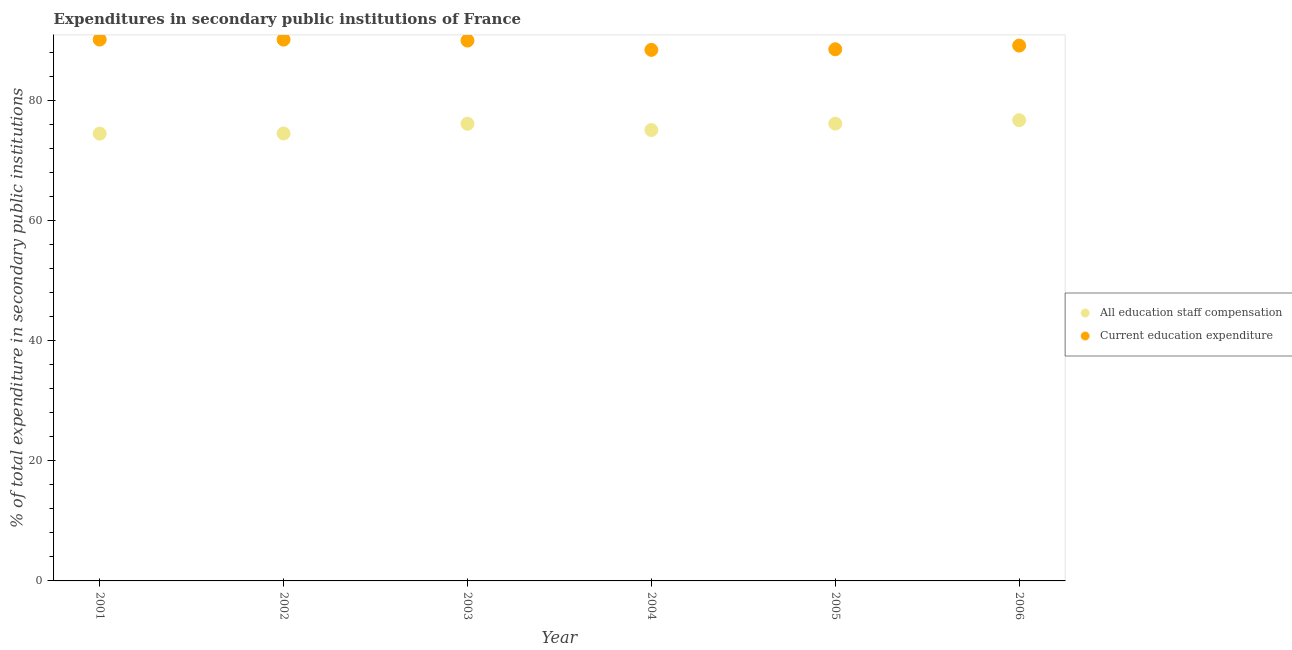What is the expenditure in education in 2003?
Your response must be concise. 90.03. Across all years, what is the maximum expenditure in staff compensation?
Keep it short and to the point. 76.76. Across all years, what is the minimum expenditure in education?
Give a very brief answer. 88.48. In which year was the expenditure in staff compensation minimum?
Your answer should be very brief. 2001. What is the total expenditure in education in the graph?
Offer a very short reply. 536.65. What is the difference between the expenditure in education in 2003 and that in 2004?
Provide a short and direct response. 1.55. What is the difference between the expenditure in education in 2001 and the expenditure in staff compensation in 2005?
Give a very brief answer. 14. What is the average expenditure in staff compensation per year?
Your answer should be very brief. 75.55. In the year 2004, what is the difference between the expenditure in education and expenditure in staff compensation?
Your response must be concise. 13.35. In how many years, is the expenditure in education greater than 44 %?
Provide a succinct answer. 6. What is the ratio of the expenditure in staff compensation in 2004 to that in 2006?
Offer a very short reply. 0.98. Is the difference between the expenditure in staff compensation in 2002 and 2005 greater than the difference between the expenditure in education in 2002 and 2005?
Your answer should be very brief. No. What is the difference between the highest and the second highest expenditure in staff compensation?
Your answer should be very brief. 0.57. What is the difference between the highest and the lowest expenditure in staff compensation?
Your response must be concise. 2.24. Is the sum of the expenditure in staff compensation in 2003 and 2004 greater than the maximum expenditure in education across all years?
Offer a very short reply. Yes. Is the expenditure in education strictly less than the expenditure in staff compensation over the years?
Your answer should be very brief. No. How many dotlines are there?
Offer a terse response. 2. What is the difference between two consecutive major ticks on the Y-axis?
Provide a short and direct response. 20. Does the graph contain any zero values?
Make the answer very short. No. Where does the legend appear in the graph?
Your answer should be very brief. Center right. What is the title of the graph?
Make the answer very short. Expenditures in secondary public institutions of France. Does "Measles" appear as one of the legend labels in the graph?
Provide a succinct answer. No. What is the label or title of the X-axis?
Offer a terse response. Year. What is the label or title of the Y-axis?
Your response must be concise. % of total expenditure in secondary public institutions. What is the % of total expenditure in secondary public institutions in All education staff compensation in 2001?
Your response must be concise. 74.53. What is the % of total expenditure in secondary public institutions in Current education expenditure in 2001?
Keep it short and to the point. 90.19. What is the % of total expenditure in secondary public institutions in All education staff compensation in 2002?
Provide a short and direct response. 74.55. What is the % of total expenditure in secondary public institutions in Current education expenditure in 2002?
Provide a succinct answer. 90.19. What is the % of total expenditure in secondary public institutions in All education staff compensation in 2003?
Make the answer very short. 76.16. What is the % of total expenditure in secondary public institutions of Current education expenditure in 2003?
Give a very brief answer. 90.03. What is the % of total expenditure in secondary public institutions of All education staff compensation in 2004?
Provide a succinct answer. 75.12. What is the % of total expenditure in secondary public institutions in Current education expenditure in 2004?
Your answer should be compact. 88.48. What is the % of total expenditure in secondary public institutions in All education staff compensation in 2005?
Ensure brevity in your answer.  76.19. What is the % of total expenditure in secondary public institutions in Current education expenditure in 2005?
Offer a very short reply. 88.58. What is the % of total expenditure in secondary public institutions in All education staff compensation in 2006?
Your answer should be compact. 76.76. What is the % of total expenditure in secondary public institutions in Current education expenditure in 2006?
Give a very brief answer. 89.19. Across all years, what is the maximum % of total expenditure in secondary public institutions in All education staff compensation?
Keep it short and to the point. 76.76. Across all years, what is the maximum % of total expenditure in secondary public institutions of Current education expenditure?
Provide a succinct answer. 90.19. Across all years, what is the minimum % of total expenditure in secondary public institutions in All education staff compensation?
Offer a very short reply. 74.53. Across all years, what is the minimum % of total expenditure in secondary public institutions in Current education expenditure?
Make the answer very short. 88.48. What is the total % of total expenditure in secondary public institutions of All education staff compensation in the graph?
Keep it short and to the point. 453.31. What is the total % of total expenditure in secondary public institutions of Current education expenditure in the graph?
Make the answer very short. 536.65. What is the difference between the % of total expenditure in secondary public institutions of All education staff compensation in 2001 and that in 2002?
Your answer should be very brief. -0.02. What is the difference between the % of total expenditure in secondary public institutions in Current education expenditure in 2001 and that in 2002?
Ensure brevity in your answer.  0. What is the difference between the % of total expenditure in secondary public institutions in All education staff compensation in 2001 and that in 2003?
Ensure brevity in your answer.  -1.64. What is the difference between the % of total expenditure in secondary public institutions of Current education expenditure in 2001 and that in 2003?
Make the answer very short. 0.17. What is the difference between the % of total expenditure in secondary public institutions in All education staff compensation in 2001 and that in 2004?
Ensure brevity in your answer.  -0.6. What is the difference between the % of total expenditure in secondary public institutions of Current education expenditure in 2001 and that in 2004?
Ensure brevity in your answer.  1.72. What is the difference between the % of total expenditure in secondary public institutions in All education staff compensation in 2001 and that in 2005?
Offer a terse response. -1.66. What is the difference between the % of total expenditure in secondary public institutions in Current education expenditure in 2001 and that in 2005?
Your response must be concise. 1.61. What is the difference between the % of total expenditure in secondary public institutions of All education staff compensation in 2001 and that in 2006?
Your answer should be compact. -2.24. What is the difference between the % of total expenditure in secondary public institutions in Current education expenditure in 2001 and that in 2006?
Your answer should be compact. 1. What is the difference between the % of total expenditure in secondary public institutions in All education staff compensation in 2002 and that in 2003?
Provide a succinct answer. -1.61. What is the difference between the % of total expenditure in secondary public institutions of Current education expenditure in 2002 and that in 2003?
Make the answer very short. 0.16. What is the difference between the % of total expenditure in secondary public institutions of All education staff compensation in 2002 and that in 2004?
Give a very brief answer. -0.57. What is the difference between the % of total expenditure in secondary public institutions of Current education expenditure in 2002 and that in 2004?
Your response must be concise. 1.71. What is the difference between the % of total expenditure in secondary public institutions in All education staff compensation in 2002 and that in 2005?
Keep it short and to the point. -1.64. What is the difference between the % of total expenditure in secondary public institutions in Current education expenditure in 2002 and that in 2005?
Your answer should be compact. 1.61. What is the difference between the % of total expenditure in secondary public institutions of All education staff compensation in 2002 and that in 2006?
Your answer should be compact. -2.21. What is the difference between the % of total expenditure in secondary public institutions in Current education expenditure in 2002 and that in 2006?
Provide a succinct answer. 1. What is the difference between the % of total expenditure in secondary public institutions of All education staff compensation in 2003 and that in 2004?
Offer a very short reply. 1.04. What is the difference between the % of total expenditure in secondary public institutions of Current education expenditure in 2003 and that in 2004?
Offer a very short reply. 1.55. What is the difference between the % of total expenditure in secondary public institutions of All education staff compensation in 2003 and that in 2005?
Your answer should be compact. -0.03. What is the difference between the % of total expenditure in secondary public institutions in Current education expenditure in 2003 and that in 2005?
Give a very brief answer. 1.45. What is the difference between the % of total expenditure in secondary public institutions in All education staff compensation in 2003 and that in 2006?
Offer a very short reply. -0.6. What is the difference between the % of total expenditure in secondary public institutions of Current education expenditure in 2003 and that in 2006?
Offer a terse response. 0.84. What is the difference between the % of total expenditure in secondary public institutions of All education staff compensation in 2004 and that in 2005?
Offer a terse response. -1.07. What is the difference between the % of total expenditure in secondary public institutions of Current education expenditure in 2004 and that in 2005?
Your response must be concise. -0.1. What is the difference between the % of total expenditure in secondary public institutions in All education staff compensation in 2004 and that in 2006?
Keep it short and to the point. -1.64. What is the difference between the % of total expenditure in secondary public institutions in Current education expenditure in 2004 and that in 2006?
Ensure brevity in your answer.  -0.72. What is the difference between the % of total expenditure in secondary public institutions in All education staff compensation in 2005 and that in 2006?
Provide a short and direct response. -0.57. What is the difference between the % of total expenditure in secondary public institutions in Current education expenditure in 2005 and that in 2006?
Provide a succinct answer. -0.61. What is the difference between the % of total expenditure in secondary public institutions of All education staff compensation in 2001 and the % of total expenditure in secondary public institutions of Current education expenditure in 2002?
Offer a terse response. -15.66. What is the difference between the % of total expenditure in secondary public institutions of All education staff compensation in 2001 and the % of total expenditure in secondary public institutions of Current education expenditure in 2003?
Offer a terse response. -15.5. What is the difference between the % of total expenditure in secondary public institutions of All education staff compensation in 2001 and the % of total expenditure in secondary public institutions of Current education expenditure in 2004?
Give a very brief answer. -13.95. What is the difference between the % of total expenditure in secondary public institutions of All education staff compensation in 2001 and the % of total expenditure in secondary public institutions of Current education expenditure in 2005?
Your answer should be compact. -14.05. What is the difference between the % of total expenditure in secondary public institutions of All education staff compensation in 2001 and the % of total expenditure in secondary public institutions of Current education expenditure in 2006?
Give a very brief answer. -14.67. What is the difference between the % of total expenditure in secondary public institutions of All education staff compensation in 2002 and the % of total expenditure in secondary public institutions of Current education expenditure in 2003?
Provide a succinct answer. -15.48. What is the difference between the % of total expenditure in secondary public institutions of All education staff compensation in 2002 and the % of total expenditure in secondary public institutions of Current education expenditure in 2004?
Offer a very short reply. -13.93. What is the difference between the % of total expenditure in secondary public institutions of All education staff compensation in 2002 and the % of total expenditure in secondary public institutions of Current education expenditure in 2005?
Offer a very short reply. -14.03. What is the difference between the % of total expenditure in secondary public institutions in All education staff compensation in 2002 and the % of total expenditure in secondary public institutions in Current education expenditure in 2006?
Provide a succinct answer. -14.64. What is the difference between the % of total expenditure in secondary public institutions of All education staff compensation in 2003 and the % of total expenditure in secondary public institutions of Current education expenditure in 2004?
Keep it short and to the point. -12.31. What is the difference between the % of total expenditure in secondary public institutions in All education staff compensation in 2003 and the % of total expenditure in secondary public institutions in Current education expenditure in 2005?
Give a very brief answer. -12.41. What is the difference between the % of total expenditure in secondary public institutions in All education staff compensation in 2003 and the % of total expenditure in secondary public institutions in Current education expenditure in 2006?
Provide a short and direct response. -13.03. What is the difference between the % of total expenditure in secondary public institutions of All education staff compensation in 2004 and the % of total expenditure in secondary public institutions of Current education expenditure in 2005?
Your answer should be very brief. -13.45. What is the difference between the % of total expenditure in secondary public institutions of All education staff compensation in 2004 and the % of total expenditure in secondary public institutions of Current education expenditure in 2006?
Give a very brief answer. -14.07. What is the difference between the % of total expenditure in secondary public institutions in All education staff compensation in 2005 and the % of total expenditure in secondary public institutions in Current education expenditure in 2006?
Give a very brief answer. -13. What is the average % of total expenditure in secondary public institutions in All education staff compensation per year?
Provide a short and direct response. 75.55. What is the average % of total expenditure in secondary public institutions of Current education expenditure per year?
Your response must be concise. 89.44. In the year 2001, what is the difference between the % of total expenditure in secondary public institutions of All education staff compensation and % of total expenditure in secondary public institutions of Current education expenditure?
Keep it short and to the point. -15.67. In the year 2002, what is the difference between the % of total expenditure in secondary public institutions of All education staff compensation and % of total expenditure in secondary public institutions of Current education expenditure?
Your answer should be compact. -15.64. In the year 2003, what is the difference between the % of total expenditure in secondary public institutions of All education staff compensation and % of total expenditure in secondary public institutions of Current education expenditure?
Provide a short and direct response. -13.86. In the year 2004, what is the difference between the % of total expenditure in secondary public institutions of All education staff compensation and % of total expenditure in secondary public institutions of Current education expenditure?
Your response must be concise. -13.35. In the year 2005, what is the difference between the % of total expenditure in secondary public institutions of All education staff compensation and % of total expenditure in secondary public institutions of Current education expenditure?
Your answer should be very brief. -12.39. In the year 2006, what is the difference between the % of total expenditure in secondary public institutions in All education staff compensation and % of total expenditure in secondary public institutions in Current education expenditure?
Your response must be concise. -12.43. What is the ratio of the % of total expenditure in secondary public institutions of All education staff compensation in 2001 to that in 2003?
Your answer should be compact. 0.98. What is the ratio of the % of total expenditure in secondary public institutions of Current education expenditure in 2001 to that in 2004?
Your answer should be very brief. 1.02. What is the ratio of the % of total expenditure in secondary public institutions in All education staff compensation in 2001 to that in 2005?
Give a very brief answer. 0.98. What is the ratio of the % of total expenditure in secondary public institutions in Current education expenditure in 2001 to that in 2005?
Make the answer very short. 1.02. What is the ratio of the % of total expenditure in secondary public institutions of All education staff compensation in 2001 to that in 2006?
Ensure brevity in your answer.  0.97. What is the ratio of the % of total expenditure in secondary public institutions in Current education expenditure in 2001 to that in 2006?
Provide a succinct answer. 1.01. What is the ratio of the % of total expenditure in secondary public institutions of All education staff compensation in 2002 to that in 2003?
Your response must be concise. 0.98. What is the ratio of the % of total expenditure in secondary public institutions in Current education expenditure in 2002 to that in 2003?
Your answer should be very brief. 1. What is the ratio of the % of total expenditure in secondary public institutions in All education staff compensation in 2002 to that in 2004?
Ensure brevity in your answer.  0.99. What is the ratio of the % of total expenditure in secondary public institutions of Current education expenditure in 2002 to that in 2004?
Your response must be concise. 1.02. What is the ratio of the % of total expenditure in secondary public institutions in All education staff compensation in 2002 to that in 2005?
Offer a very short reply. 0.98. What is the ratio of the % of total expenditure in secondary public institutions of Current education expenditure in 2002 to that in 2005?
Your response must be concise. 1.02. What is the ratio of the % of total expenditure in secondary public institutions of All education staff compensation in 2002 to that in 2006?
Your answer should be very brief. 0.97. What is the ratio of the % of total expenditure in secondary public institutions of Current education expenditure in 2002 to that in 2006?
Offer a terse response. 1.01. What is the ratio of the % of total expenditure in secondary public institutions of All education staff compensation in 2003 to that in 2004?
Your response must be concise. 1.01. What is the ratio of the % of total expenditure in secondary public institutions in Current education expenditure in 2003 to that in 2004?
Make the answer very short. 1.02. What is the ratio of the % of total expenditure in secondary public institutions of Current education expenditure in 2003 to that in 2005?
Keep it short and to the point. 1.02. What is the ratio of the % of total expenditure in secondary public institutions of All education staff compensation in 2003 to that in 2006?
Your answer should be very brief. 0.99. What is the ratio of the % of total expenditure in secondary public institutions of Current education expenditure in 2003 to that in 2006?
Make the answer very short. 1.01. What is the ratio of the % of total expenditure in secondary public institutions of All education staff compensation in 2004 to that in 2005?
Give a very brief answer. 0.99. What is the ratio of the % of total expenditure in secondary public institutions of All education staff compensation in 2004 to that in 2006?
Your response must be concise. 0.98. What is the ratio of the % of total expenditure in secondary public institutions of Current education expenditure in 2005 to that in 2006?
Provide a succinct answer. 0.99. What is the difference between the highest and the second highest % of total expenditure in secondary public institutions of All education staff compensation?
Your response must be concise. 0.57. What is the difference between the highest and the second highest % of total expenditure in secondary public institutions in Current education expenditure?
Give a very brief answer. 0. What is the difference between the highest and the lowest % of total expenditure in secondary public institutions of All education staff compensation?
Ensure brevity in your answer.  2.24. What is the difference between the highest and the lowest % of total expenditure in secondary public institutions in Current education expenditure?
Make the answer very short. 1.72. 